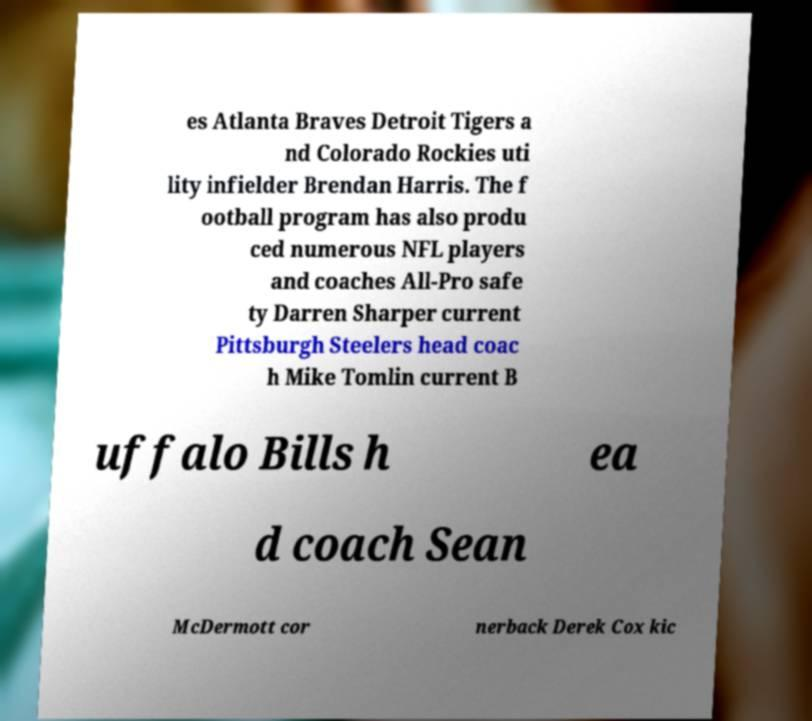Can you read and provide the text displayed in the image?This photo seems to have some interesting text. Can you extract and type it out for me? es Atlanta Braves Detroit Tigers a nd Colorado Rockies uti lity infielder Brendan Harris. The f ootball program has also produ ced numerous NFL players and coaches All-Pro safe ty Darren Sharper current Pittsburgh Steelers head coac h Mike Tomlin current B uffalo Bills h ea d coach Sean McDermott cor nerback Derek Cox kic 